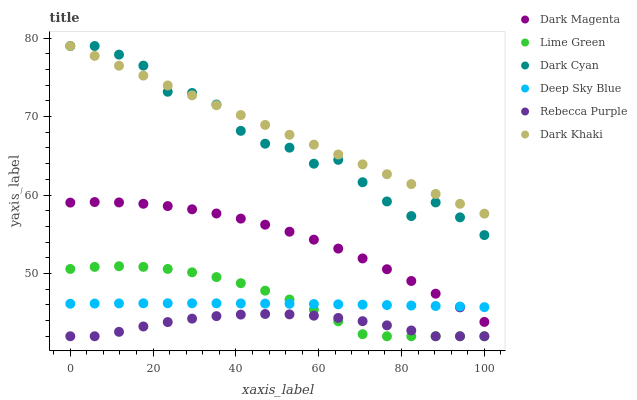Does Rebecca Purple have the minimum area under the curve?
Answer yes or no. Yes. Does Dark Khaki have the maximum area under the curve?
Answer yes or no. Yes. Does Dark Khaki have the minimum area under the curve?
Answer yes or no. No. Does Rebecca Purple have the maximum area under the curve?
Answer yes or no. No. Is Dark Khaki the smoothest?
Answer yes or no. Yes. Is Dark Cyan the roughest?
Answer yes or no. Yes. Is Rebecca Purple the smoothest?
Answer yes or no. No. Is Rebecca Purple the roughest?
Answer yes or no. No. Does Rebecca Purple have the lowest value?
Answer yes or no. Yes. Does Dark Khaki have the lowest value?
Answer yes or no. No. Does Dark Cyan have the highest value?
Answer yes or no. Yes. Does Rebecca Purple have the highest value?
Answer yes or no. No. Is Deep Sky Blue less than Dark Cyan?
Answer yes or no. Yes. Is Dark Cyan greater than Rebecca Purple?
Answer yes or no. Yes. Does Rebecca Purple intersect Lime Green?
Answer yes or no. Yes. Is Rebecca Purple less than Lime Green?
Answer yes or no. No. Is Rebecca Purple greater than Lime Green?
Answer yes or no. No. Does Deep Sky Blue intersect Dark Cyan?
Answer yes or no. No. 